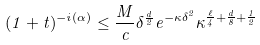<formula> <loc_0><loc_0><loc_500><loc_500>( 1 + t ) ^ { - i ( \alpha ) } \leq \frac { M } { c } \delta ^ { \frac { d } { 2 } } e ^ { - \kappa \delta ^ { 2 } } \kappa ^ { \frac { \ell } { 4 } + \frac { d } { 8 } + \frac { 1 } { 2 } }</formula> 